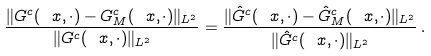<formula> <loc_0><loc_0><loc_500><loc_500>\frac { \| G ^ { c } ( \ x , \cdot ) - G ^ { c } _ { M } ( \ x , \cdot ) \| _ { L ^ { 2 } } } { \| G ^ { c } ( \ x , \cdot ) \| _ { L ^ { 2 } } } = \frac { \| \hat { G } ^ { c } ( \ x , \cdot ) - \hat { G } ^ { c } _ { M } ( \ x , \cdot ) \| _ { L ^ { 2 } } } { \| \hat { G } ^ { c } ( \ x , \cdot ) \| _ { L ^ { 2 } } } \, .</formula> 